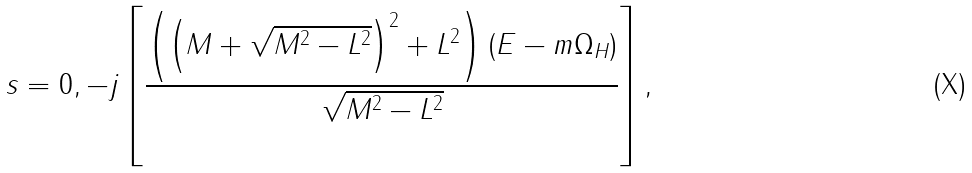Convert formula to latex. <formula><loc_0><loc_0><loc_500><loc_500>s = 0 , - j \left [ \frac { \left ( \left ( M + \sqrt { M ^ { 2 } - L ^ { 2 } } \right ) ^ { 2 } + L ^ { 2 } \right ) ( E - m \Omega _ { H } ) } { \sqrt { M ^ { 2 } - L ^ { 2 } } } \right ] ,</formula> 